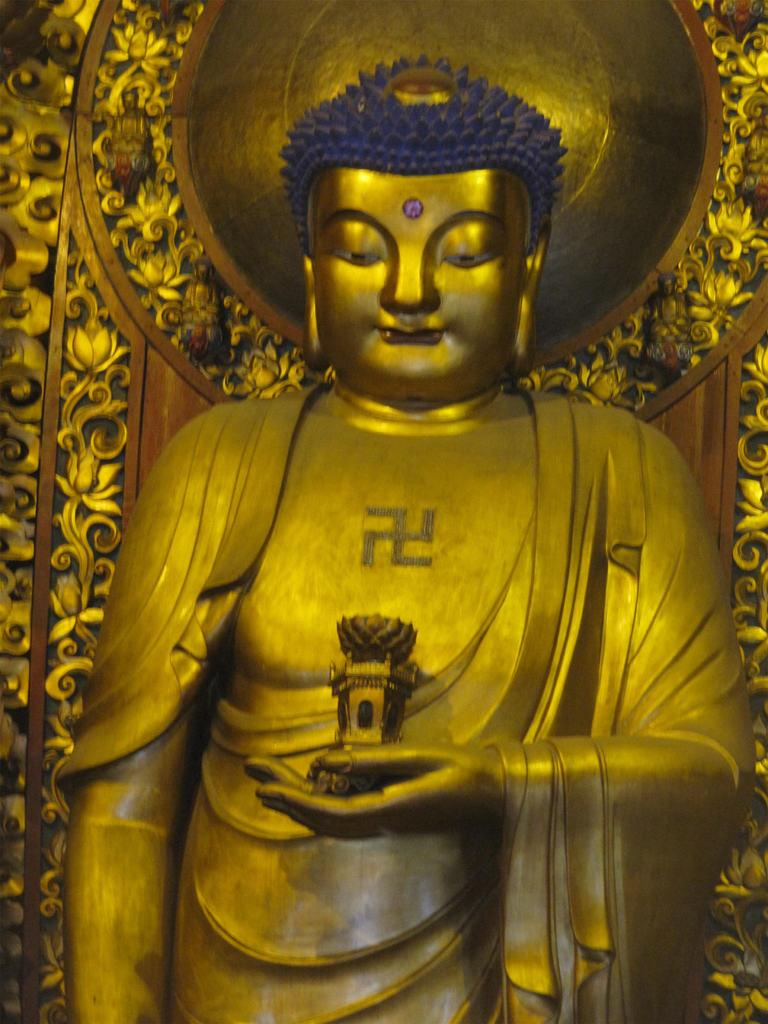What is the main subject of the image? There is a statue in the image. What is the statue holding in its hand? The statue has an object in its hand. What is the color of the statue and the object it is holding? The statue and the object are in golden color. What type of headwear does the statue have? The statue has a crown. What is the color of the crown? The crown is in blue color. Can you tell me how many toads are sitting on the statue's head in the image? There are no toads present in the image; the statue has a crown on its head. What type of hen can be seen perched on the statue's shoulder in the image? There is no hen present in the image; the statue has a crown on its head and is holding an object in its hand. 